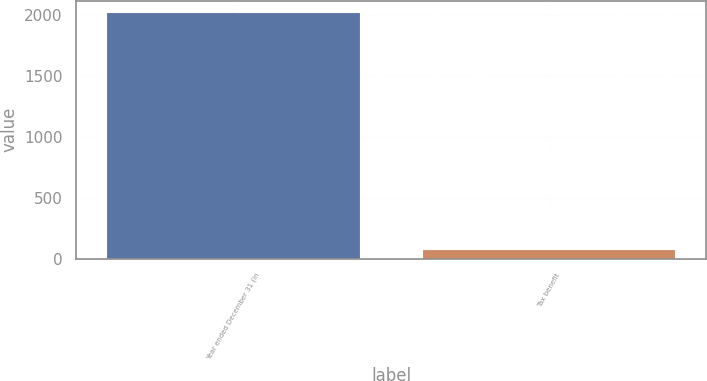<chart> <loc_0><loc_0><loc_500><loc_500><bar_chart><fcel>Year ended December 31 (in<fcel>Tax benefit<nl><fcel>2016<fcel>70<nl></chart> 